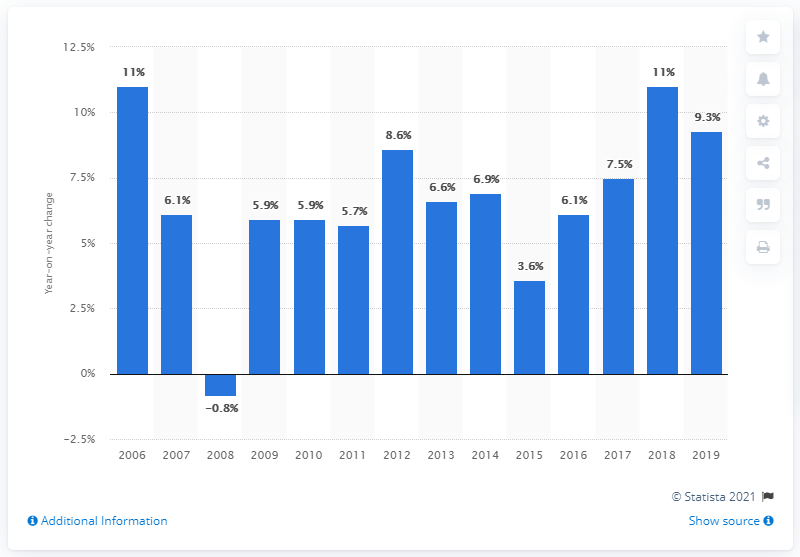Give some essential details in this illustration. In 2019, the travel and tourism industry in China contributed 9.3% to the country's GDP. In 2018, the travel and tourism industry in China contributed 9.3% to the country's GDP. 